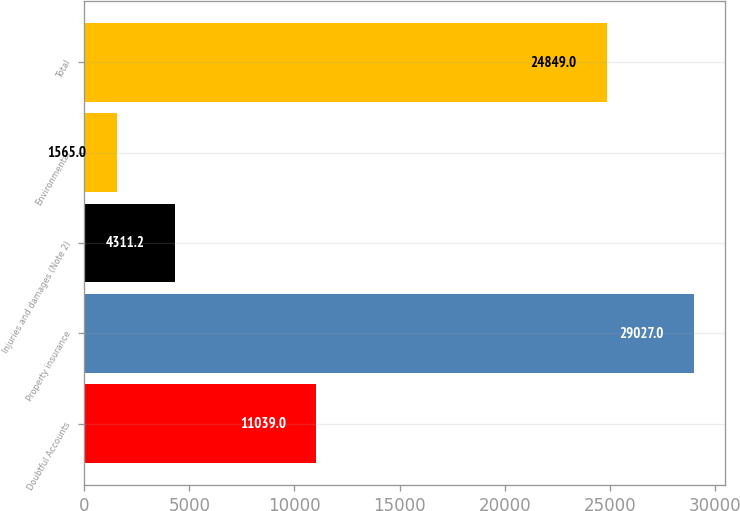<chart> <loc_0><loc_0><loc_500><loc_500><bar_chart><fcel>Doubtful Accounts<fcel>Property insurance<fcel>Injuries and damages (Note 2)<fcel>Environmental<fcel>Total<nl><fcel>11039<fcel>29027<fcel>4311.2<fcel>1565<fcel>24849<nl></chart> 